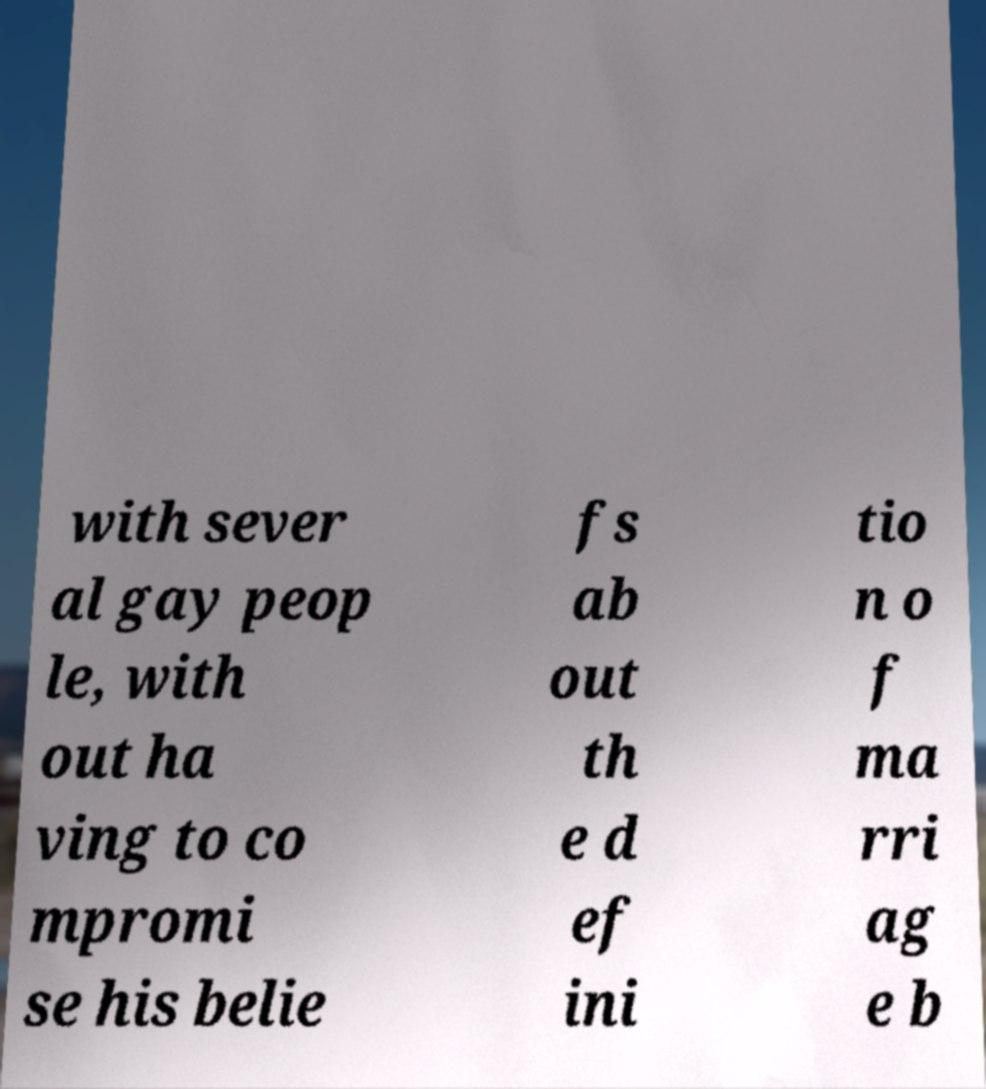What messages or text are displayed in this image? I need them in a readable, typed format. with sever al gay peop le, with out ha ving to co mpromi se his belie fs ab out th e d ef ini tio n o f ma rri ag e b 